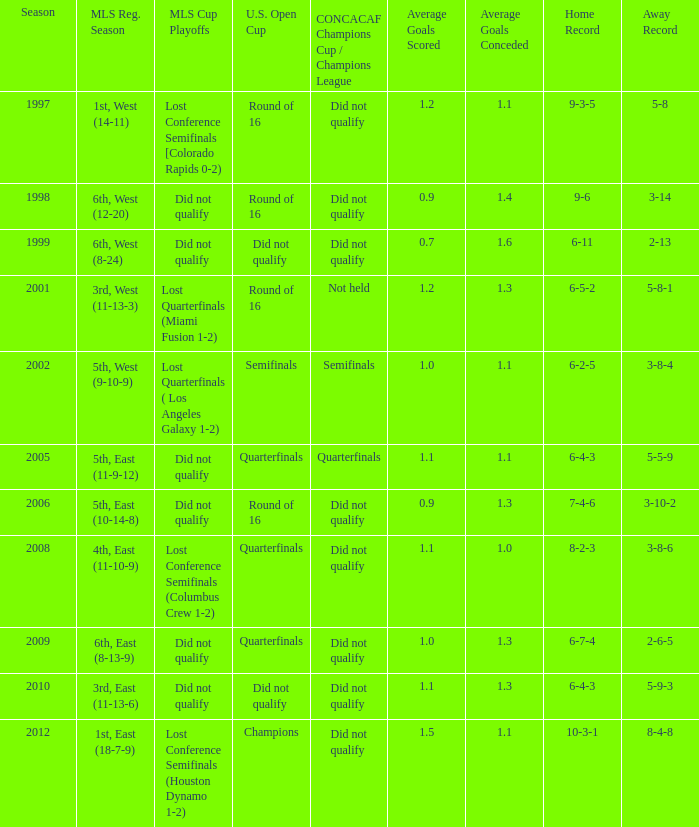What were the placements of the team in regular season when they reached quarterfinals in the U.S. Open Cup but did not qualify for the Concaf Champions Cup? 4th, East (11-10-9), 6th, East (8-13-9). 